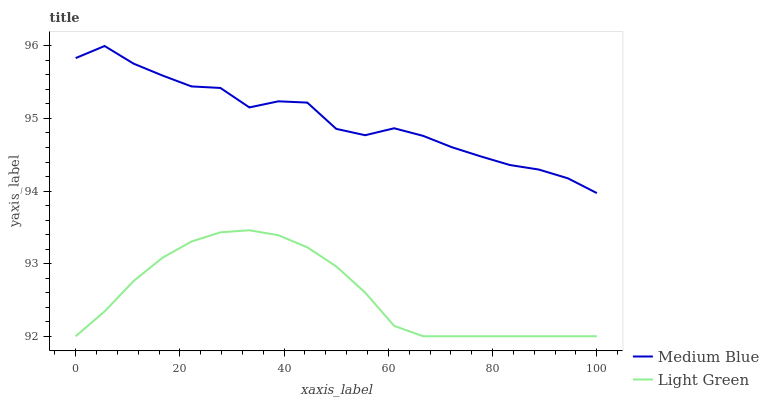Does Light Green have the maximum area under the curve?
Answer yes or no. No. Is Light Green the roughest?
Answer yes or no. No. Does Light Green have the highest value?
Answer yes or no. No. Is Light Green less than Medium Blue?
Answer yes or no. Yes. Is Medium Blue greater than Light Green?
Answer yes or no. Yes. Does Light Green intersect Medium Blue?
Answer yes or no. No. 